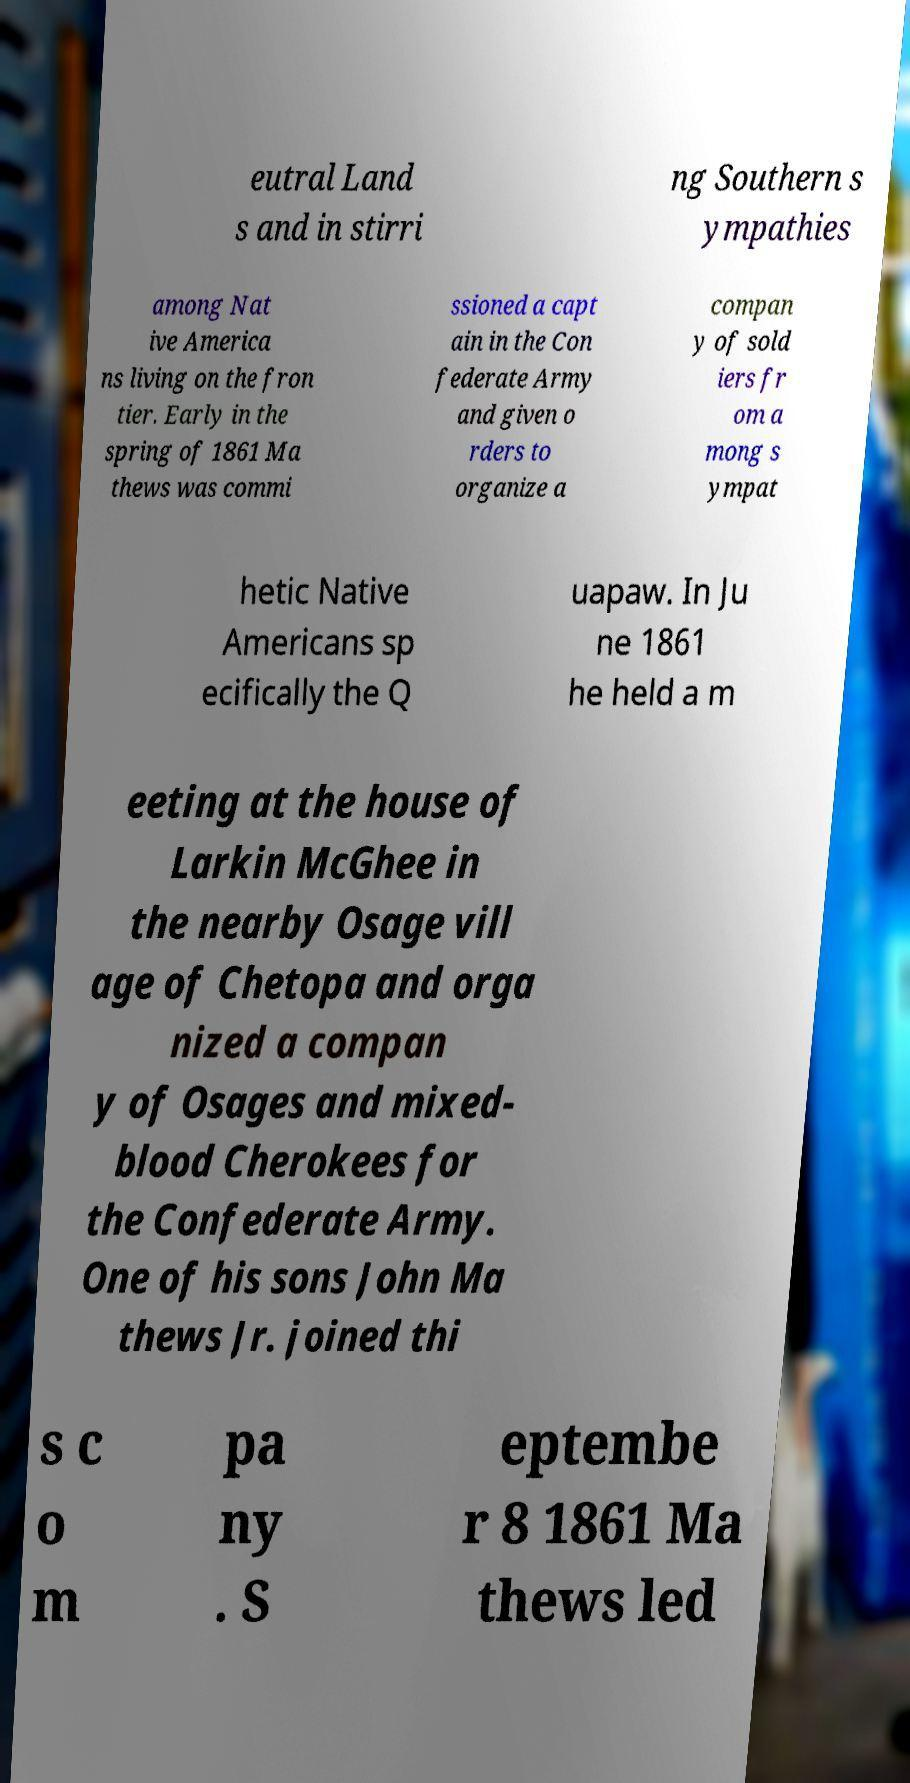There's text embedded in this image that I need extracted. Can you transcribe it verbatim? eutral Land s and in stirri ng Southern s ympathies among Nat ive America ns living on the fron tier. Early in the spring of 1861 Ma thews was commi ssioned a capt ain in the Con federate Army and given o rders to organize a compan y of sold iers fr om a mong s ympat hetic Native Americans sp ecifically the Q uapaw. In Ju ne 1861 he held a m eeting at the house of Larkin McGhee in the nearby Osage vill age of Chetopa and orga nized a compan y of Osages and mixed- blood Cherokees for the Confederate Army. One of his sons John Ma thews Jr. joined thi s c o m pa ny . S eptembe r 8 1861 Ma thews led 